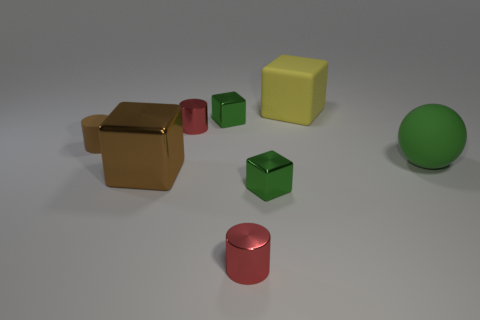Are there more red objects in front of the large brown object than small cylinders in front of the rubber sphere?
Offer a terse response. No. There is a brown thing that is the same size as the green matte object; what is its material?
Give a very brief answer. Metal. There is a yellow rubber thing; what shape is it?
Ensure brevity in your answer.  Cube. What number of brown objects are either tiny cylinders or balls?
Offer a terse response. 1. There is a brown object that is the same material as the green ball; what is its size?
Give a very brief answer. Small. Is the material of the brown object that is in front of the brown cylinder the same as the tiny block that is in front of the tiny brown rubber cylinder?
Your answer should be compact. Yes. How many cylinders are either small yellow metal objects or brown objects?
Keep it short and to the point. 1. How many brown metal cubes are behind the large thing that is on the left side of the rubber block that is behind the matte cylinder?
Provide a succinct answer. 0. There is a brown object that is the same shape as the big yellow object; what is its material?
Offer a very short reply. Metal. There is a matte object left of the rubber block; what is its color?
Your answer should be compact. Brown. 